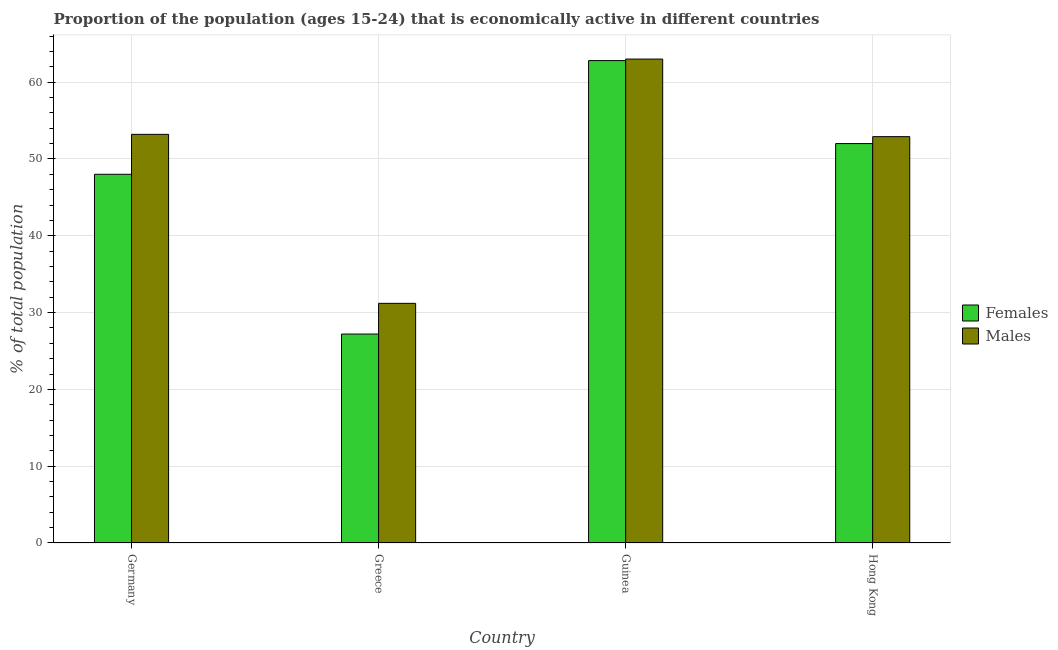Are the number of bars per tick equal to the number of legend labels?
Your answer should be compact. Yes. Are the number of bars on each tick of the X-axis equal?
Keep it short and to the point. Yes. What is the label of the 4th group of bars from the left?
Make the answer very short. Hong Kong. In how many cases, is the number of bars for a given country not equal to the number of legend labels?
Your answer should be very brief. 0. Across all countries, what is the maximum percentage of economically active female population?
Offer a very short reply. 62.8. Across all countries, what is the minimum percentage of economically active male population?
Offer a very short reply. 31.2. In which country was the percentage of economically active female population maximum?
Provide a succinct answer. Guinea. In which country was the percentage of economically active male population minimum?
Offer a very short reply. Greece. What is the total percentage of economically active male population in the graph?
Offer a very short reply. 200.3. What is the difference between the percentage of economically active female population in Germany and the percentage of economically active male population in Hong Kong?
Your answer should be compact. -4.9. What is the average percentage of economically active male population per country?
Make the answer very short. 50.08. What is the difference between the percentage of economically active male population and percentage of economically active female population in Guinea?
Ensure brevity in your answer.  0.2. In how many countries, is the percentage of economically active male population greater than 38 %?
Your answer should be compact. 3. What is the ratio of the percentage of economically active female population in Guinea to that in Hong Kong?
Provide a short and direct response. 1.21. Is the percentage of economically active male population in Guinea less than that in Hong Kong?
Provide a short and direct response. No. Is the difference between the percentage of economically active male population in Greece and Guinea greater than the difference between the percentage of economically active female population in Greece and Guinea?
Your answer should be very brief. Yes. What is the difference between the highest and the second highest percentage of economically active female population?
Offer a very short reply. 10.8. What is the difference between the highest and the lowest percentage of economically active male population?
Give a very brief answer. 31.8. Is the sum of the percentage of economically active female population in Germany and Greece greater than the maximum percentage of economically active male population across all countries?
Give a very brief answer. Yes. What does the 1st bar from the left in Hong Kong represents?
Your response must be concise. Females. What does the 1st bar from the right in Guinea represents?
Offer a very short reply. Males. How many bars are there?
Give a very brief answer. 8. Are all the bars in the graph horizontal?
Provide a succinct answer. No. How many countries are there in the graph?
Make the answer very short. 4. Where does the legend appear in the graph?
Your answer should be compact. Center right. How are the legend labels stacked?
Your answer should be very brief. Vertical. What is the title of the graph?
Your response must be concise. Proportion of the population (ages 15-24) that is economically active in different countries. Does "Formally registered" appear as one of the legend labels in the graph?
Your response must be concise. No. What is the label or title of the Y-axis?
Give a very brief answer. % of total population. What is the % of total population of Females in Germany?
Give a very brief answer. 48. What is the % of total population in Males in Germany?
Make the answer very short. 53.2. What is the % of total population in Females in Greece?
Offer a very short reply. 27.2. What is the % of total population of Males in Greece?
Ensure brevity in your answer.  31.2. What is the % of total population of Females in Guinea?
Your response must be concise. 62.8. What is the % of total population of Males in Guinea?
Your answer should be very brief. 63. What is the % of total population of Males in Hong Kong?
Ensure brevity in your answer.  52.9. Across all countries, what is the maximum % of total population of Females?
Your answer should be very brief. 62.8. Across all countries, what is the maximum % of total population in Males?
Keep it short and to the point. 63. Across all countries, what is the minimum % of total population in Females?
Provide a short and direct response. 27.2. Across all countries, what is the minimum % of total population in Males?
Provide a short and direct response. 31.2. What is the total % of total population in Females in the graph?
Make the answer very short. 190. What is the total % of total population of Males in the graph?
Your answer should be very brief. 200.3. What is the difference between the % of total population of Females in Germany and that in Greece?
Offer a terse response. 20.8. What is the difference between the % of total population in Males in Germany and that in Greece?
Provide a succinct answer. 22. What is the difference between the % of total population of Females in Germany and that in Guinea?
Offer a very short reply. -14.8. What is the difference between the % of total population of Females in Germany and that in Hong Kong?
Offer a terse response. -4. What is the difference between the % of total population in Males in Germany and that in Hong Kong?
Your response must be concise. 0.3. What is the difference between the % of total population in Females in Greece and that in Guinea?
Provide a short and direct response. -35.6. What is the difference between the % of total population in Males in Greece and that in Guinea?
Make the answer very short. -31.8. What is the difference between the % of total population in Females in Greece and that in Hong Kong?
Provide a succinct answer. -24.8. What is the difference between the % of total population in Males in Greece and that in Hong Kong?
Make the answer very short. -21.7. What is the difference between the % of total population in Females in Guinea and that in Hong Kong?
Give a very brief answer. 10.8. What is the difference between the % of total population of Females in Germany and the % of total population of Males in Guinea?
Provide a succinct answer. -15. What is the difference between the % of total population of Females in Germany and the % of total population of Males in Hong Kong?
Ensure brevity in your answer.  -4.9. What is the difference between the % of total population in Females in Greece and the % of total population in Males in Guinea?
Your answer should be compact. -35.8. What is the difference between the % of total population in Females in Greece and the % of total population in Males in Hong Kong?
Ensure brevity in your answer.  -25.7. What is the difference between the % of total population of Females in Guinea and the % of total population of Males in Hong Kong?
Provide a short and direct response. 9.9. What is the average % of total population of Females per country?
Provide a succinct answer. 47.5. What is the average % of total population of Males per country?
Offer a very short reply. 50.08. What is the difference between the % of total population in Females and % of total population in Males in Guinea?
Keep it short and to the point. -0.2. What is the difference between the % of total population in Females and % of total population in Males in Hong Kong?
Offer a very short reply. -0.9. What is the ratio of the % of total population of Females in Germany to that in Greece?
Your response must be concise. 1.76. What is the ratio of the % of total population of Males in Germany to that in Greece?
Keep it short and to the point. 1.71. What is the ratio of the % of total population in Females in Germany to that in Guinea?
Make the answer very short. 0.76. What is the ratio of the % of total population of Males in Germany to that in Guinea?
Offer a very short reply. 0.84. What is the ratio of the % of total population of Males in Germany to that in Hong Kong?
Keep it short and to the point. 1.01. What is the ratio of the % of total population of Females in Greece to that in Guinea?
Offer a very short reply. 0.43. What is the ratio of the % of total population in Males in Greece to that in Guinea?
Your answer should be compact. 0.5. What is the ratio of the % of total population in Females in Greece to that in Hong Kong?
Ensure brevity in your answer.  0.52. What is the ratio of the % of total population of Males in Greece to that in Hong Kong?
Your answer should be very brief. 0.59. What is the ratio of the % of total population of Females in Guinea to that in Hong Kong?
Provide a succinct answer. 1.21. What is the ratio of the % of total population in Males in Guinea to that in Hong Kong?
Provide a short and direct response. 1.19. What is the difference between the highest and the lowest % of total population in Females?
Offer a terse response. 35.6. What is the difference between the highest and the lowest % of total population of Males?
Your response must be concise. 31.8. 